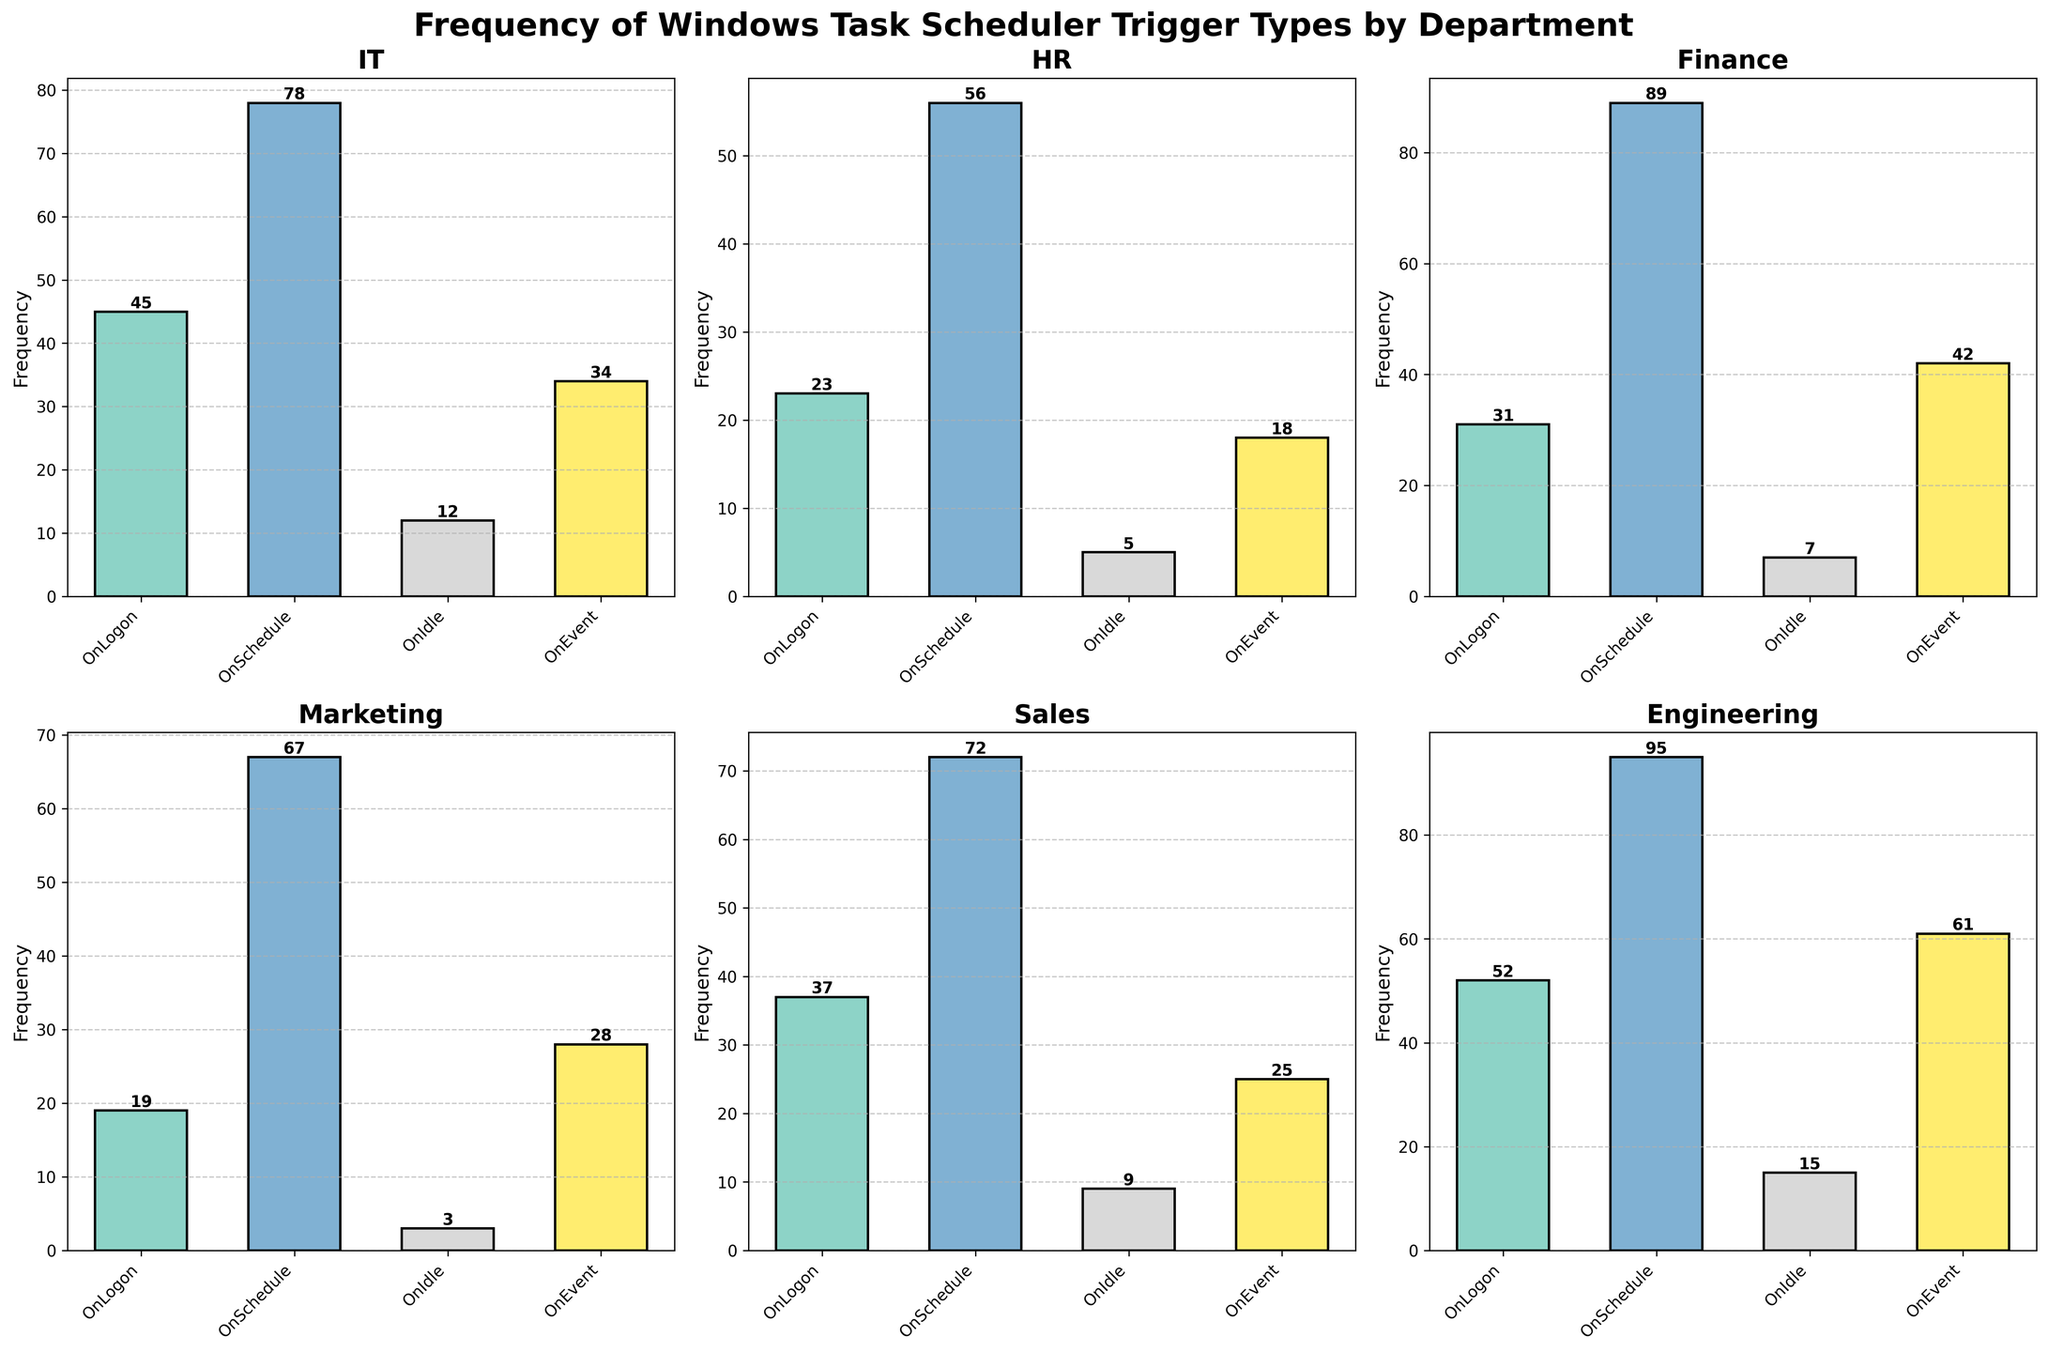Which department has the highest frequency for the "OnSchedule" trigger type? Look for the bar labeled "OnSchedule" in each subplot. The highest bar for "OnSchedule" is in the Engineering department.
Answer: Engineering What is the total frequency of the "OnLogon" trigger type across all departments? Add the frequencies of "OnLogon" for all departments: IT (45) + HR (23) + Finance (31) + Marketing (19) + Sales (37) + Engineering (52) = 45 + 23 + 31 + 19 + 37 + 52
Answer: 207 Which department uses the "OnEvent" trigger type the least? Look for the smallest bar labeled "OnEvent" in each subplot. The smallest bar for "OnEvent" is in the HR department.
Answer: HR How many departments are using the "OnIdle" trigger type? Count the number of subplots that have a bar representing "OnIdle." All six departments have a frequency bar for "OnIdle," so the number is 6.
Answer: 6 What is the difference in frequency of the "OnEvent" trigger type between Finance and Marketing? Look at the "OnEvent" bars in the Finance and Marketing subplots: Finance (42) - Marketing (28) = 42 - 28
Answer: 14 Which trigger type is used most frequently by the Sales department? Identify the bar with the highest value in the Sales subplot. The highest frequency bar is for "OnSchedule."
Answer: OnSchedule What is the average frequency of the "OnIdle" trigger type across all departments? Sum the frequencies of "OnIdle" for all departments and divide by the number of departments: (12 + 5 + 7 + 3 + 9 + 15) / 6 = 51 / 6
Answer: 8.5 Between which two departments is the greatest difference in the frequency of the "OnEvent" trigger type? Compare the frequencies of "OnEvent" for all departments and find the greatest difference: Engineering (61) - HR (18) = 61 - 18
Answer: Engineering and HR 